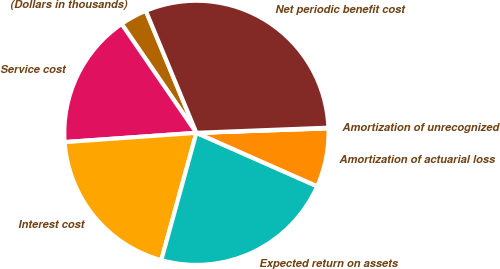Convert chart to OTSL. <chart><loc_0><loc_0><loc_500><loc_500><pie_chart><fcel>(Dollars in thousands)<fcel>Service cost<fcel>Interest cost<fcel>Expected return on assets<fcel>Amortization of actuarial loss<fcel>Amortization of unrecognized<fcel>Net periodic benefit cost<nl><fcel>3.33%<fcel>16.54%<fcel>19.6%<fcel>22.65%<fcel>7.17%<fcel>0.08%<fcel>30.63%<nl></chart> 